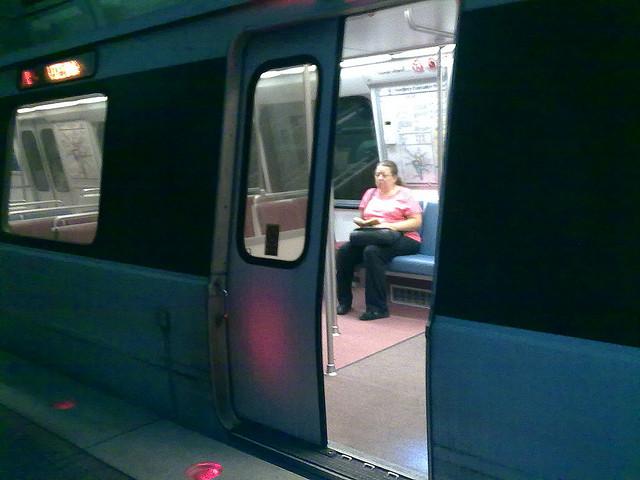Is the woman all by herself?
Be succinct. Yes. Are there any passengers on the subway?
Write a very short answer. Yes. How many people are on the train?
Be succinct. 1. Are the doors to the train open?
Give a very brief answer. Yes. Is this train full of people?
Keep it brief. No. 